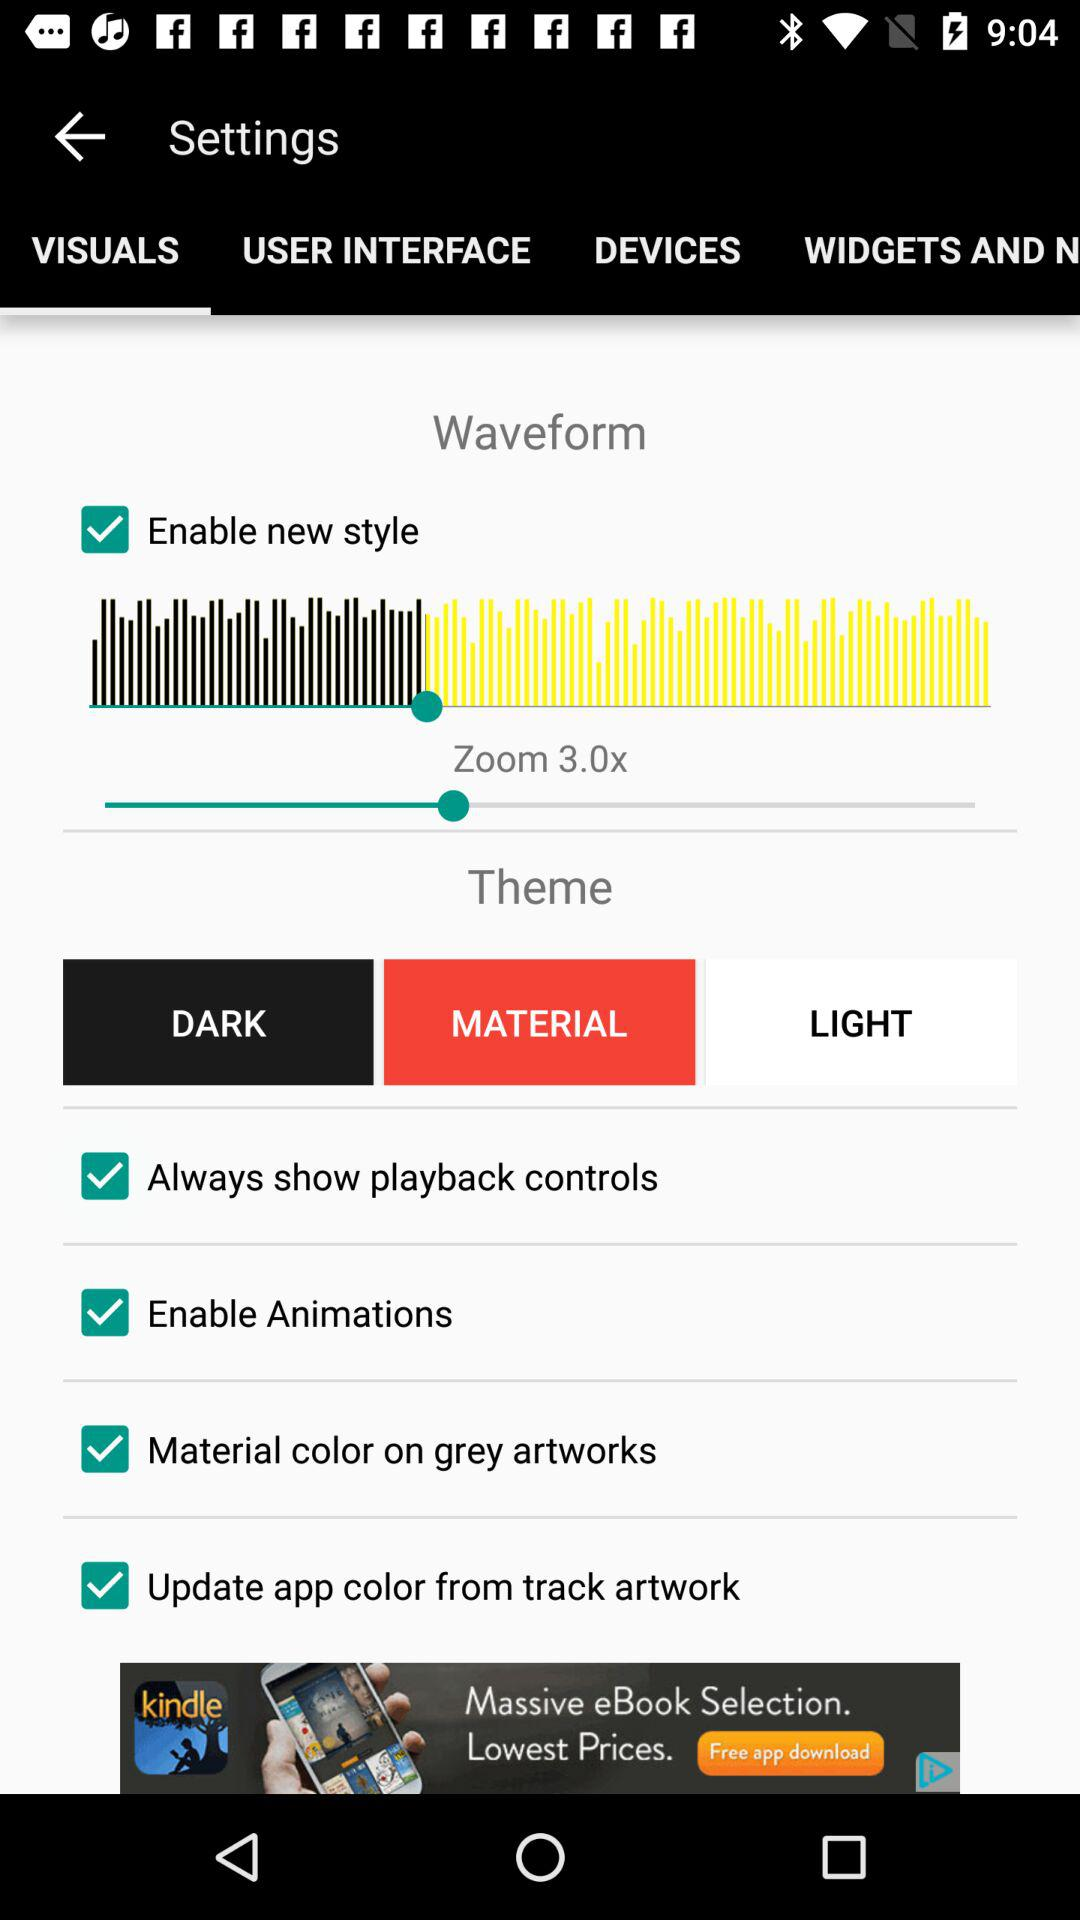What is the current status of the update app color from track artwork? The status is on. 